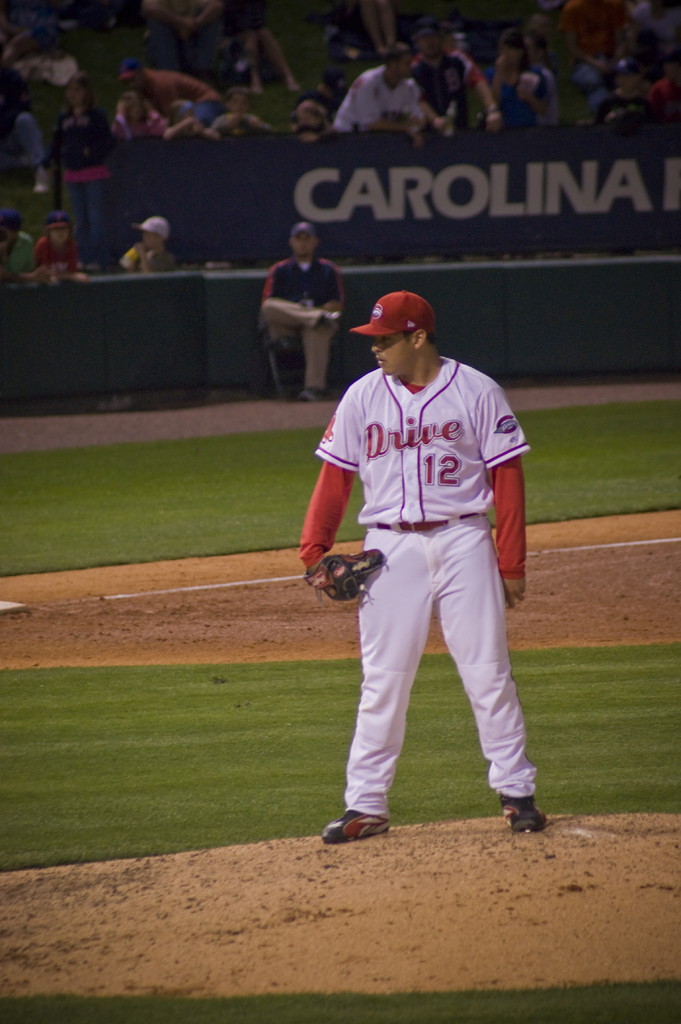Provide a one-sentence caption for the provided image.
Reference OCR token: CAROLINA, Drive, D, 2112, 12 a baseball player with a red uniform with drive 12 printed on it. 